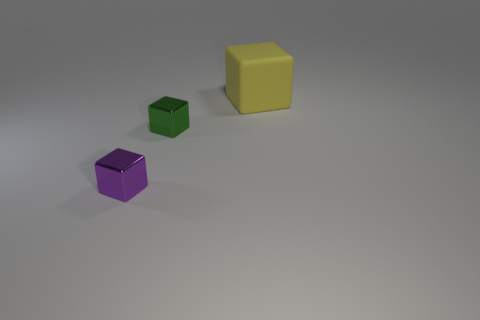Is there any other thing that has the same material as the yellow block?
Your answer should be very brief. No. The purple metal object that is the same shape as the tiny green thing is what size?
Make the answer very short. Small. Are there any tiny purple things made of the same material as the small green cube?
Offer a terse response. Yes. Is the number of tiny red blocks greater than the number of small purple metallic objects?
Provide a succinct answer. No. Is the material of the purple cube the same as the tiny green thing?
Give a very brief answer. Yes. How many metallic things are green blocks or cubes?
Offer a terse response. 2. There is a thing that is the same size as the green cube; what color is it?
Give a very brief answer. Purple. How many green metallic objects have the same shape as the large rubber object?
Your answer should be very brief. 1. How many cubes are either large brown things or yellow things?
Your response must be concise. 1. Does the thing behind the small green metallic cube have the same shape as the small metal thing that is behind the tiny purple metallic block?
Offer a very short reply. Yes. 